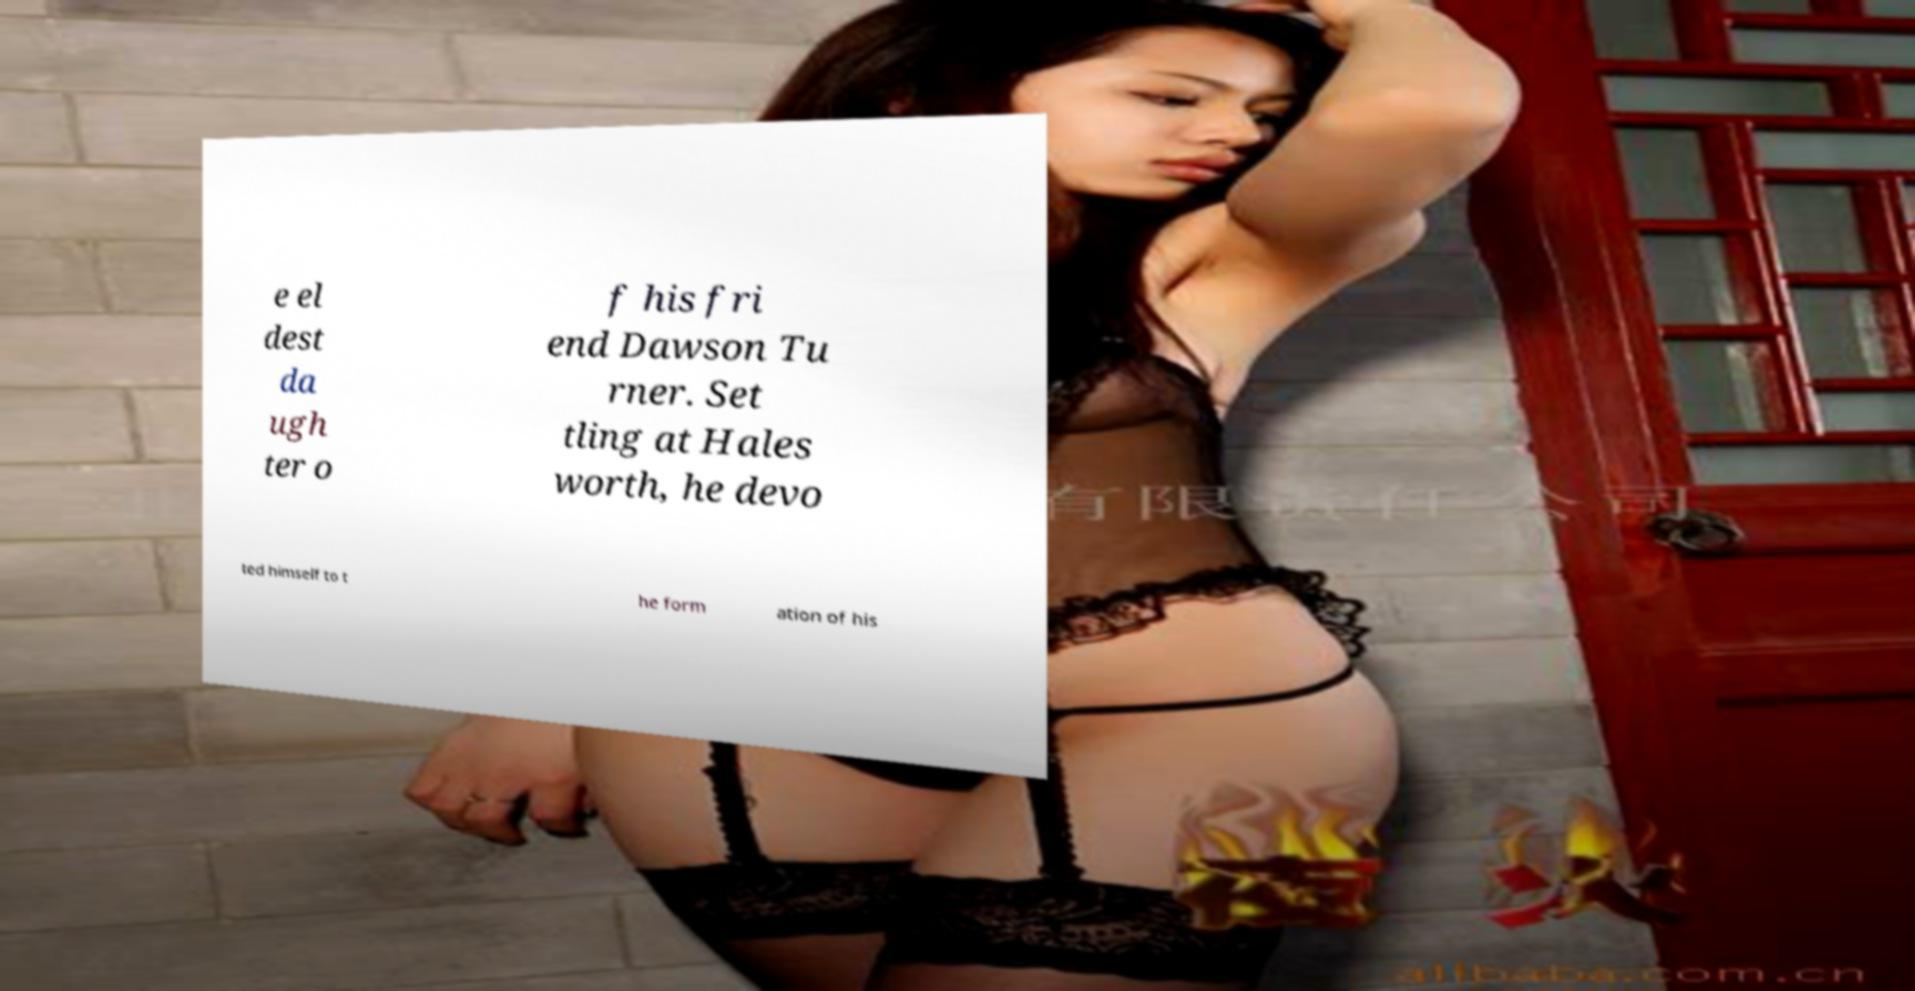Can you accurately transcribe the text from the provided image for me? e el dest da ugh ter o f his fri end Dawson Tu rner. Set tling at Hales worth, he devo ted himself to t he form ation of his 